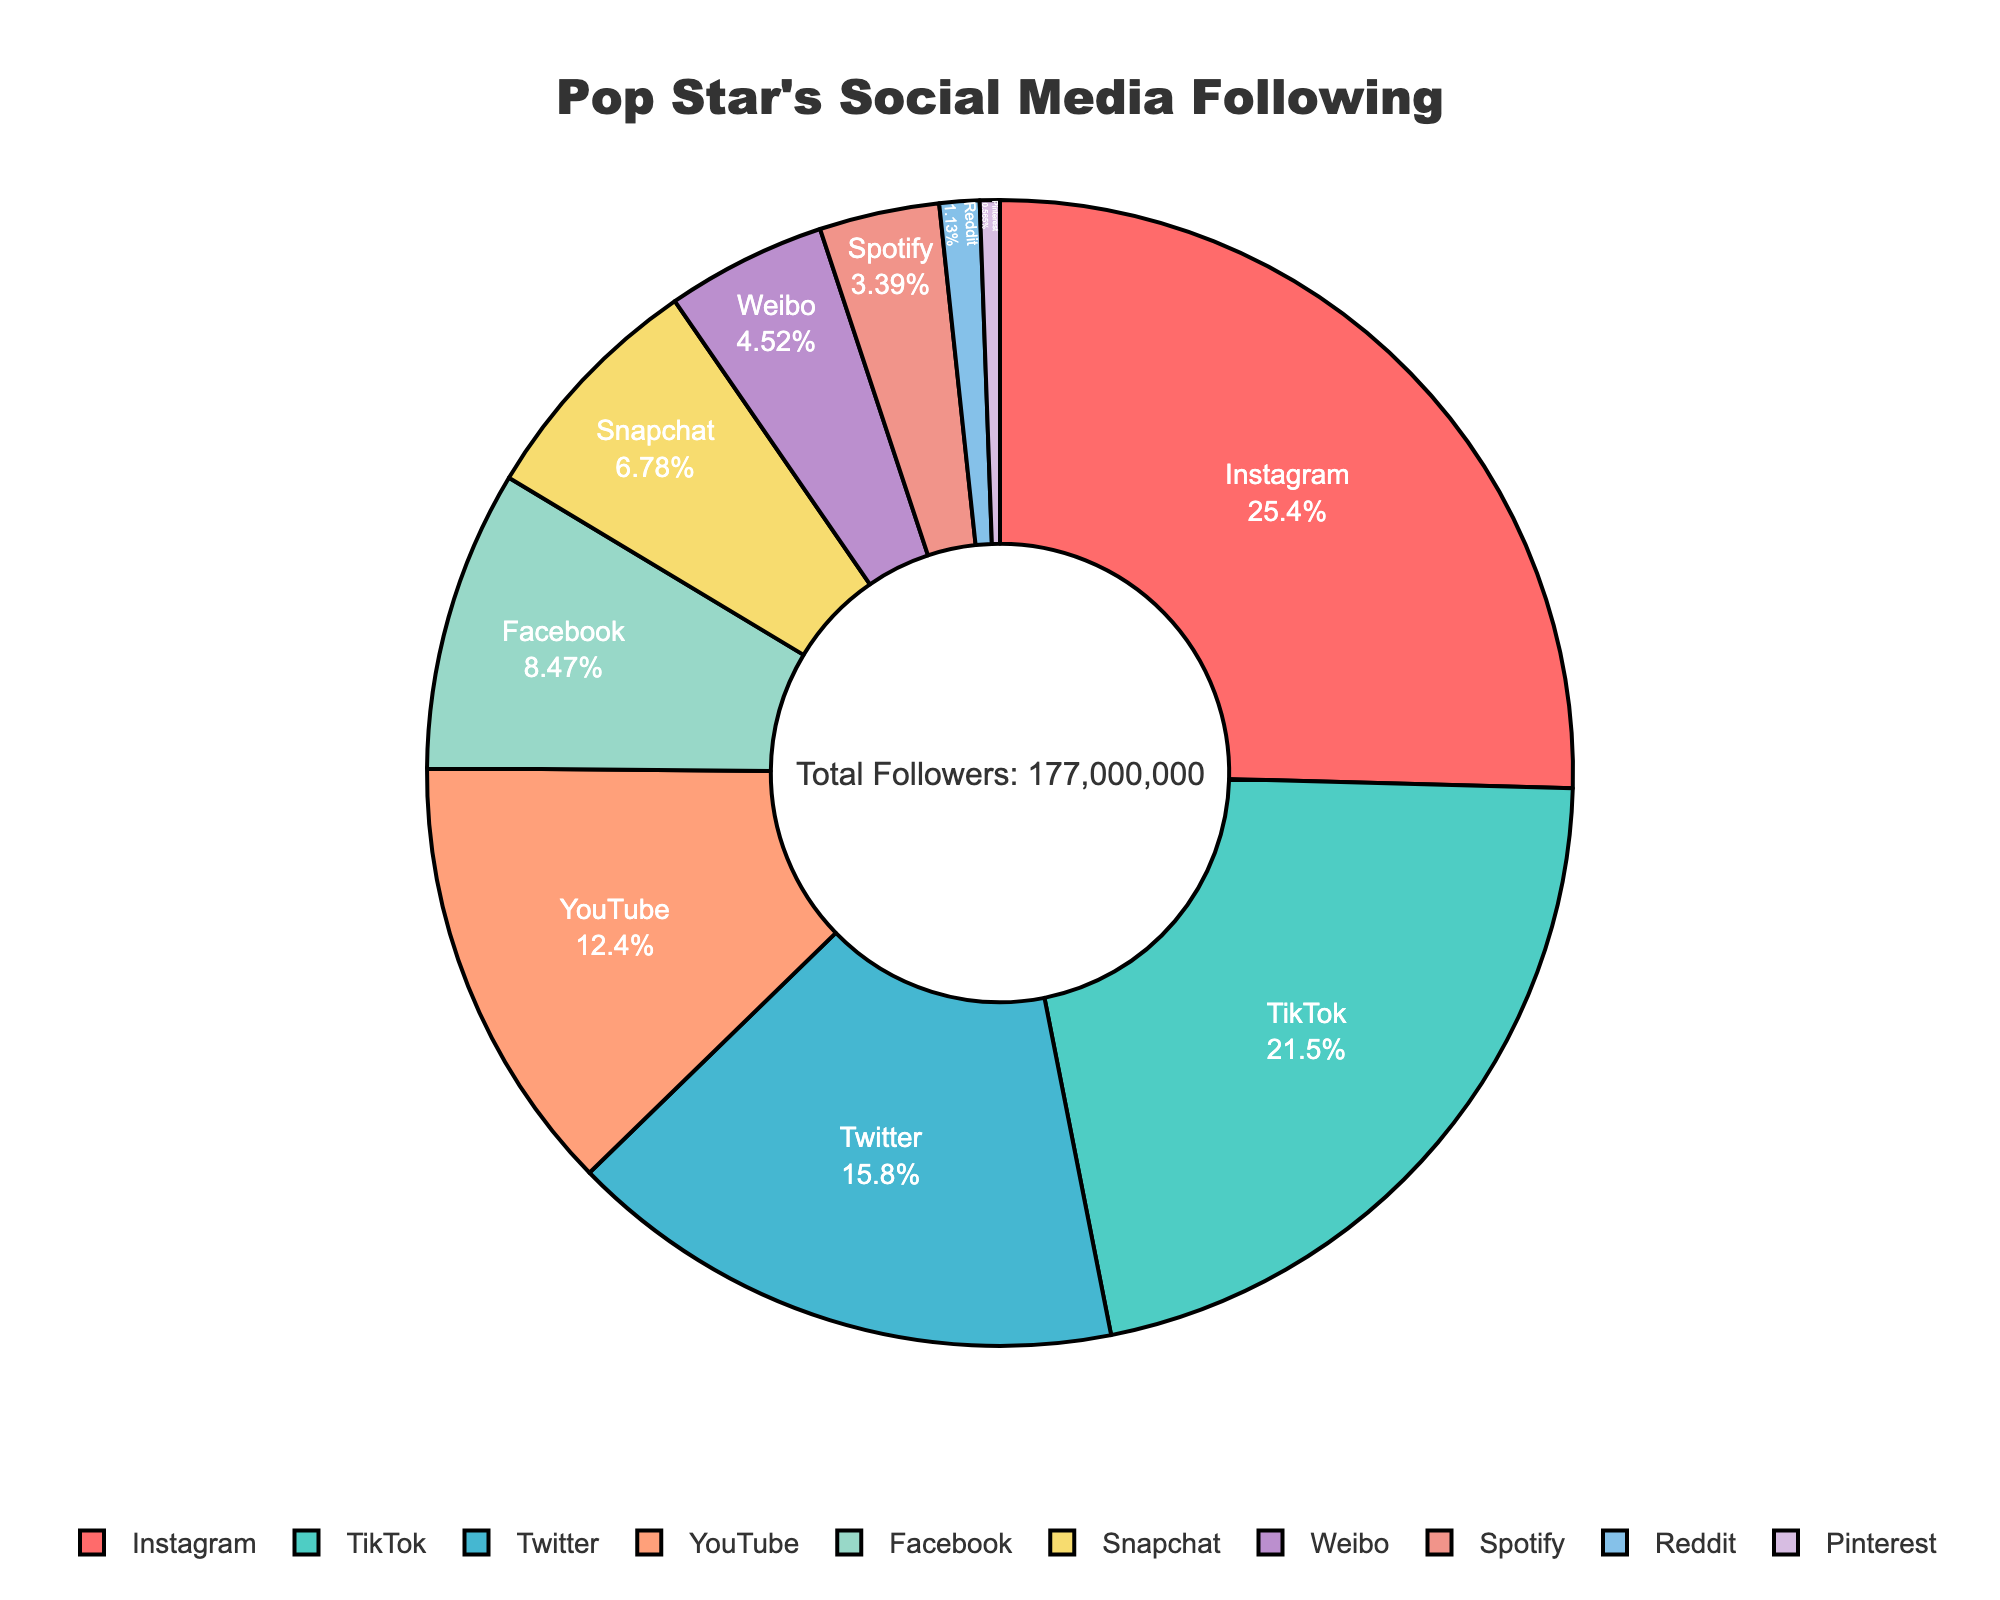What is the percentage of followers on Instagram? Find the Instagram segment and check its percentage, which is displayed inside the pie chart.
Answer: 31.03% Which platform has the least followers and what is its percentage? Identify the smallest segment in the pie chart, read the label and percentage inside.
Answer: Pinterest, 0.69% How many more followers does TikTok have compared to YouTube? Look at the follower count for TikTok and YouTube, and calculate the difference: 38,000,000 - 22,000,000.
Answer: 16,000,000 What is the combined percentage of followers on Snapchat, Weibo, and Spotify? Add the percentages from the segments for Snapchat, Weibo, and Spotify: 8.28% + 5.52% + 4.14%.
Answer: 17.94% Are there any platforms that have more followers than Facebook but less than Twitter? If so, which ones? Identify and compare the follower count of Facebook, Twitter, and the other platforms. TikTok has more than Facebook but less than Twitter.
Answer: TikTok What is the total percentage of followers for Instagram and TikTok combined? Add the percentages of Instagram and TikTok from the pie chart: 31.03% + 26.21%.
Answer: 57.24% Which platform's segment is colored blue and what is its percentage of followers? Identify the segment with the blue color and read its percentage from inside the pie chart.
Answer: Twitter, 19.31% How does the number of Twitter followers compare to the number of YouTube followers? Compare the follower count of Twitter and YouTube, and note that Twitter has more followers.
Answer: Twitter has more What is the central annotation text in the pie chart? Look at the center of the pie chart, read the text displayed there summarizing total followers.
Answer: Total Followers: 180,000,000 